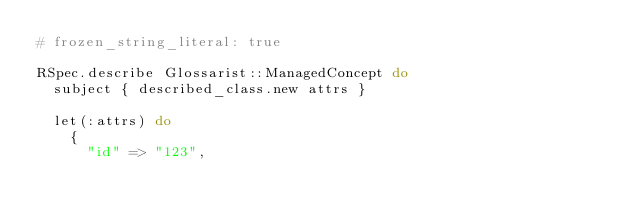<code> <loc_0><loc_0><loc_500><loc_500><_Ruby_># frozen_string_literal: true

RSpec.describe Glossarist::ManagedConcept do
  subject { described_class.new attrs }

  let(:attrs) do
    {
      "id" => "123",</code> 